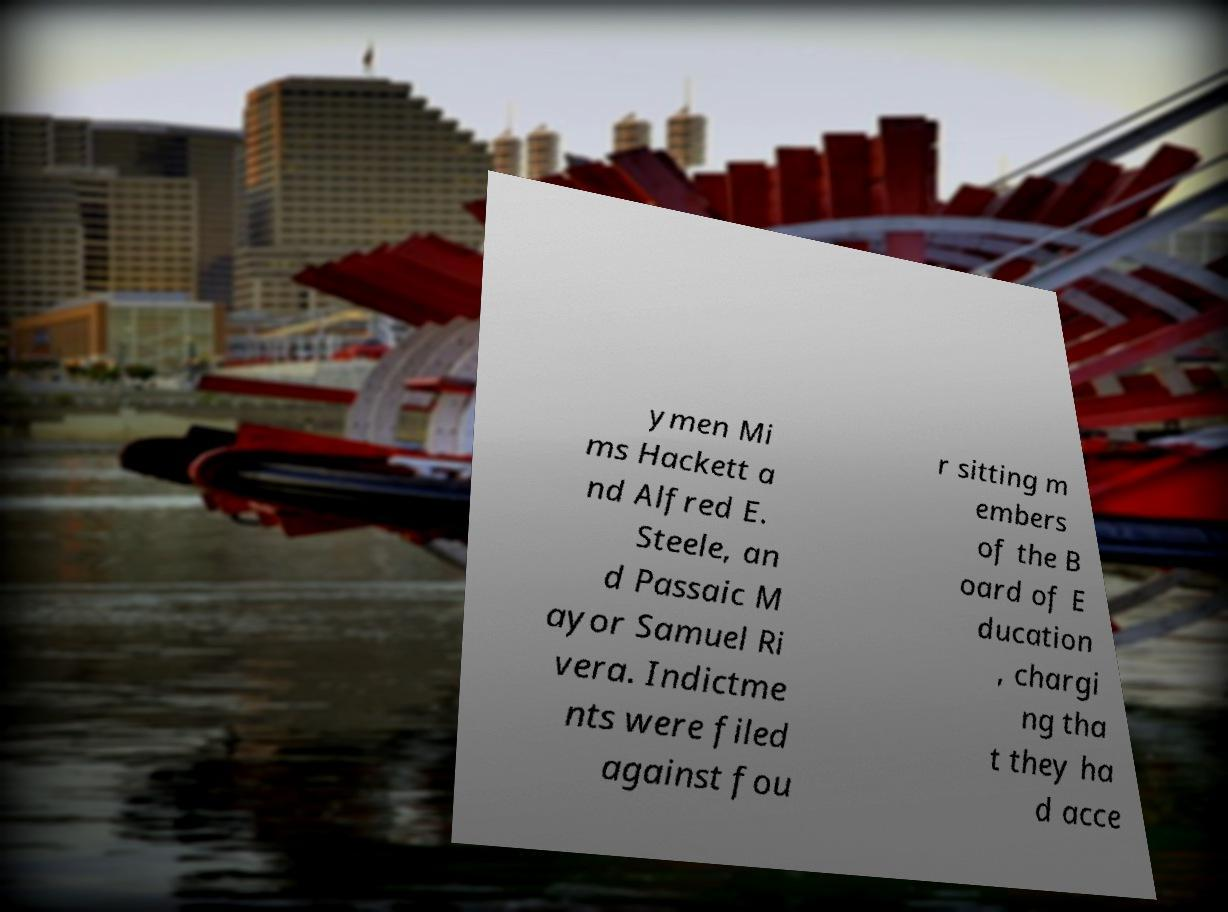Could you extract and type out the text from this image? ymen Mi ms Hackett a nd Alfred E. Steele, an d Passaic M ayor Samuel Ri vera. Indictme nts were filed against fou r sitting m embers of the B oard of E ducation , chargi ng tha t they ha d acce 